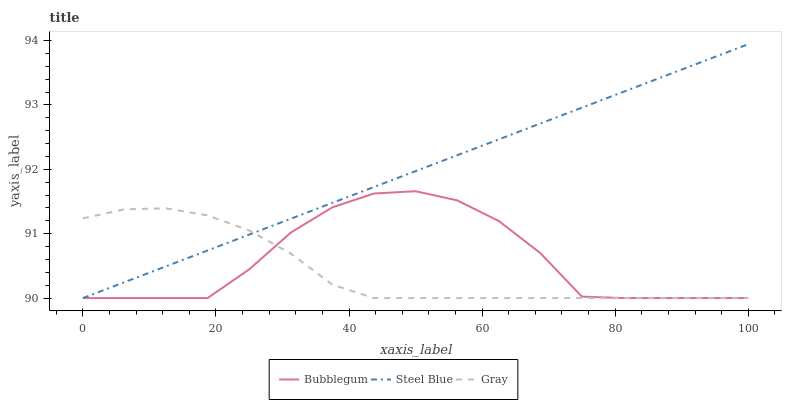Does Gray have the minimum area under the curve?
Answer yes or no. Yes. Does Steel Blue have the maximum area under the curve?
Answer yes or no. Yes. Does Bubblegum have the minimum area under the curve?
Answer yes or no. No. Does Bubblegum have the maximum area under the curve?
Answer yes or no. No. Is Steel Blue the smoothest?
Answer yes or no. Yes. Is Bubblegum the roughest?
Answer yes or no. Yes. Is Bubblegum the smoothest?
Answer yes or no. No. Is Steel Blue the roughest?
Answer yes or no. No. Does Gray have the lowest value?
Answer yes or no. Yes. Does Steel Blue have the highest value?
Answer yes or no. Yes. Does Bubblegum have the highest value?
Answer yes or no. No. Does Steel Blue intersect Bubblegum?
Answer yes or no. Yes. Is Steel Blue less than Bubblegum?
Answer yes or no. No. Is Steel Blue greater than Bubblegum?
Answer yes or no. No. 